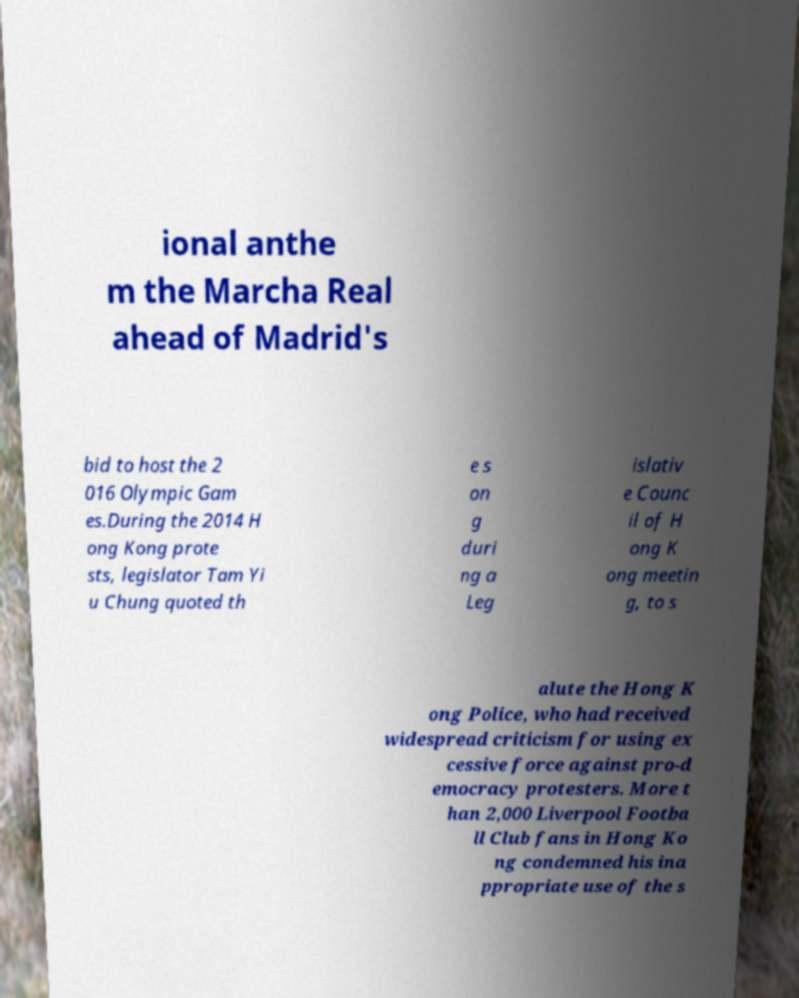Please read and relay the text visible in this image. What does it say? ional anthe m the Marcha Real ahead of Madrid's bid to host the 2 016 Olympic Gam es.During the 2014 H ong Kong prote sts, legislator Tam Yi u Chung quoted th e s on g duri ng a Leg islativ e Counc il of H ong K ong meetin g, to s alute the Hong K ong Police, who had received widespread criticism for using ex cessive force against pro-d emocracy protesters. More t han 2,000 Liverpool Footba ll Club fans in Hong Ko ng condemned his ina ppropriate use of the s 